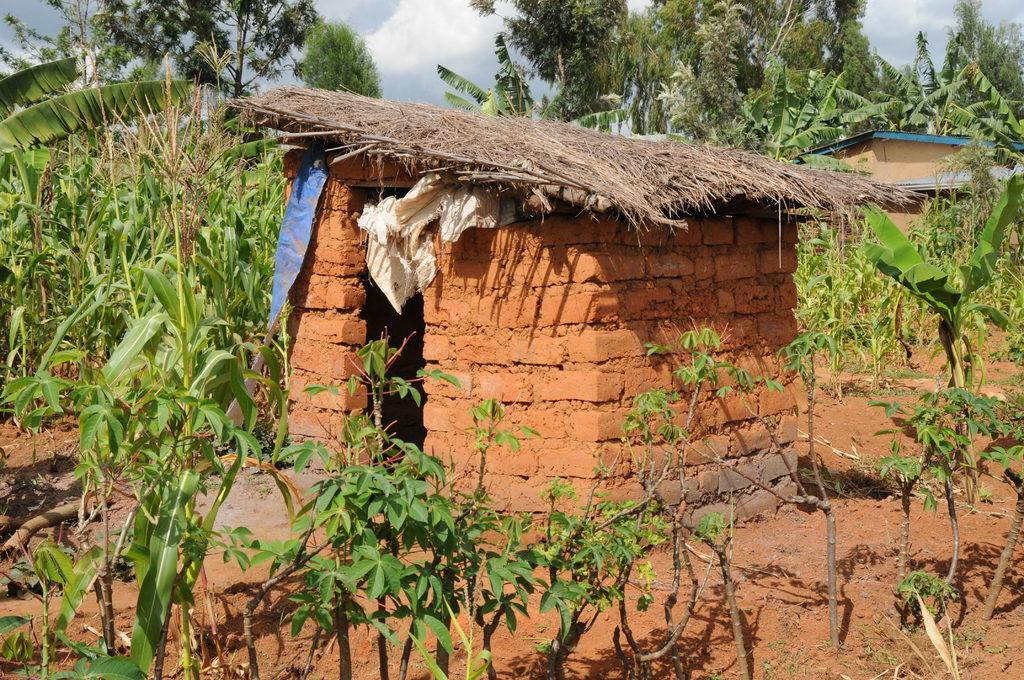What is the main structure in the center of the image? There is a hut in the center of the image. What type of vegetation is at the bottom of the image? There are plants at the bottom of the image. What can be seen in the background of the image? There are trees and the sky visible in the background of the image. What other structure is present in the image? There is a shed on the right side of the image. What type of land is being offered by the owl in the image? There is no owl present in the image, so no land is being offered. 